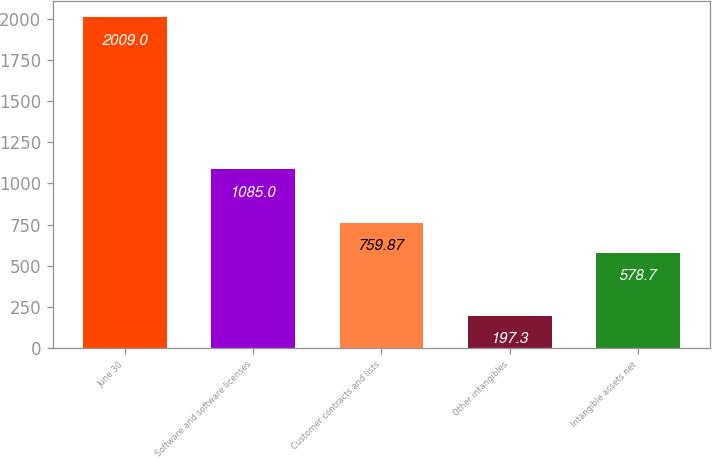Convert chart to OTSL. <chart><loc_0><loc_0><loc_500><loc_500><bar_chart><fcel>June 30<fcel>Software and software licenses<fcel>Customer contracts and lists<fcel>Other intangibles<fcel>Intangible assets net<nl><fcel>2009<fcel>1085<fcel>759.87<fcel>197.3<fcel>578.7<nl></chart> 